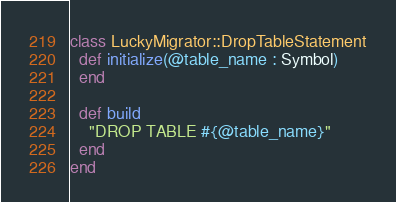<code> <loc_0><loc_0><loc_500><loc_500><_Crystal_>class LuckyMigrator::DropTableStatement
  def initialize(@table_name : Symbol)
  end

  def build
    "DROP TABLE #{@table_name}"
  end
end
</code> 